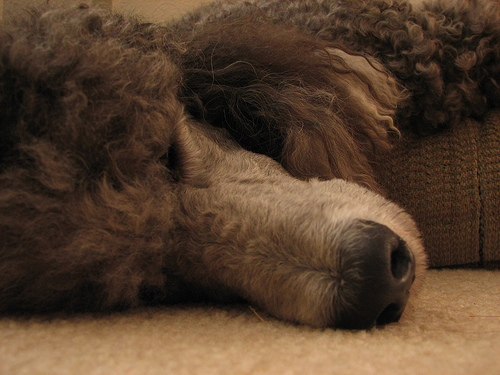<image>
Is there a dog above the floor? No. The dog is not positioned above the floor. The vertical arrangement shows a different relationship. 